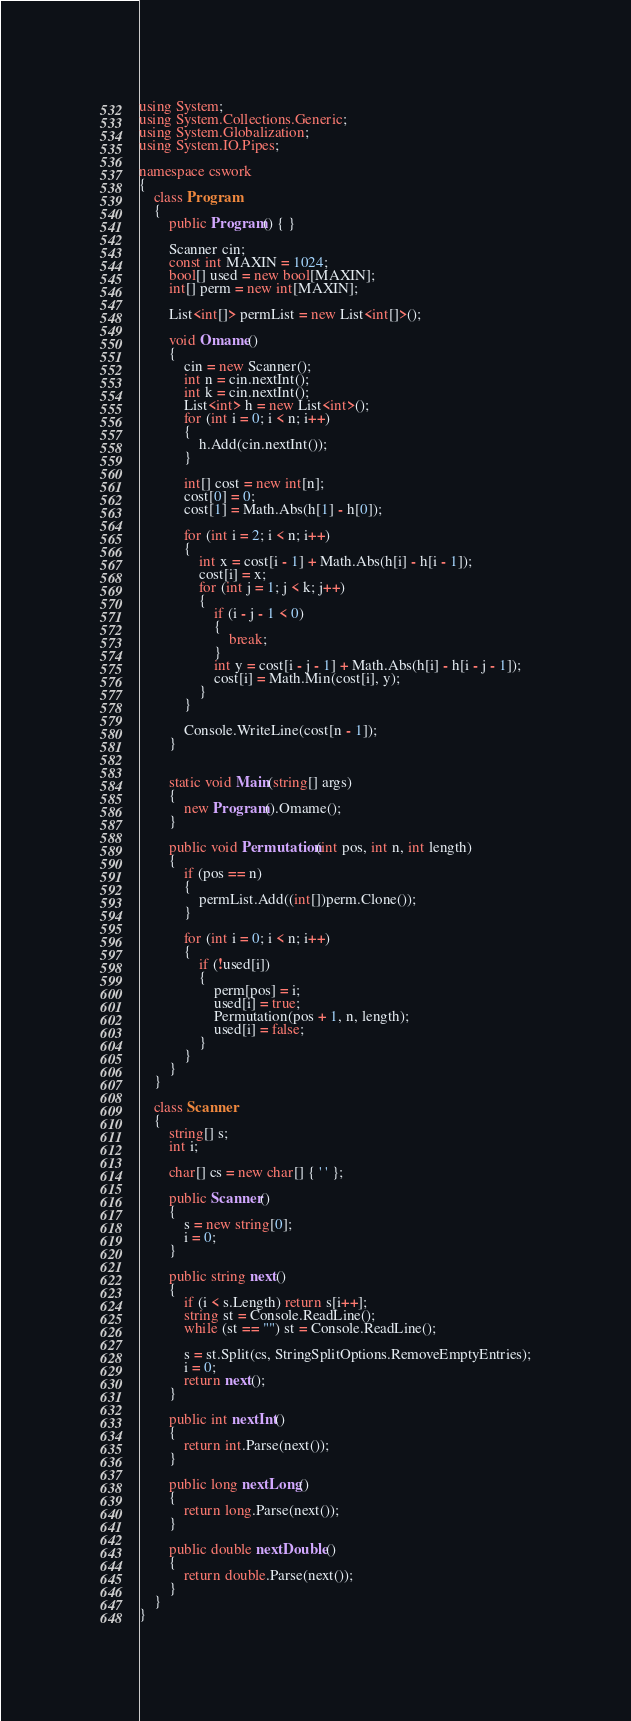Convert code to text. <code><loc_0><loc_0><loc_500><loc_500><_C#_>using System;
using System.Collections.Generic;
using System.Globalization;
using System.IO.Pipes;

namespace cswork
{
    class Program
    {
        public Program() { }

        Scanner cin;
        const int MAXIN = 1024;
        bool[] used = new bool[MAXIN];
        int[] perm = new int[MAXIN];

        List<int[]> permList = new List<int[]>();

        void Omame()
        {
            cin = new Scanner();
            int n = cin.nextInt();
            int k = cin.nextInt();
            List<int> h = new List<int>();
            for (int i = 0; i < n; i++)
            {
                h.Add(cin.nextInt());
            }

            int[] cost = new int[n];
            cost[0] = 0;
            cost[1] = Math.Abs(h[1] - h[0]);

            for (int i = 2; i < n; i++)
            {
                int x = cost[i - 1] + Math.Abs(h[i] - h[i - 1]);
                cost[i] = x;
                for (int j = 1; j < k; j++)
                {
                    if (i - j - 1 < 0)
                    {
                        break;
                    }
                    int y = cost[i - j - 1] + Math.Abs(h[i] - h[i - j - 1]);
                    cost[i] = Math.Min(cost[i], y);
                }
            }

            Console.WriteLine(cost[n - 1]);
        }


        static void Main(string[] args)
        {
            new Program().Omame();
        }

        public void Permutation(int pos, int n, int length)
        {
            if (pos == n)
            {
                permList.Add((int[])perm.Clone());
            }

            for (int i = 0; i < n; i++)
            {
                if (!used[i])
                {
                    perm[pos] = i;
                    used[i] = true;
                    Permutation(pos + 1, n, length);
                    used[i] = false;
                }
            }
        }
    }

    class Scanner
    {
        string[] s;
        int i;

        char[] cs = new char[] { ' ' };

        public Scanner()
        {
            s = new string[0];
            i = 0;
        }

        public string next()
        {
            if (i < s.Length) return s[i++];
            string st = Console.ReadLine();
            while (st == "") st = Console.ReadLine();

            s = st.Split(cs, StringSplitOptions.RemoveEmptyEntries);
            i = 0;
            return next();
        }

        public int nextInt()
        {
            return int.Parse(next());
        }

        public long nextLong()
        {
            return long.Parse(next());
        }

        public double nextDouble()
        {
            return double.Parse(next());
        }
    }
}</code> 